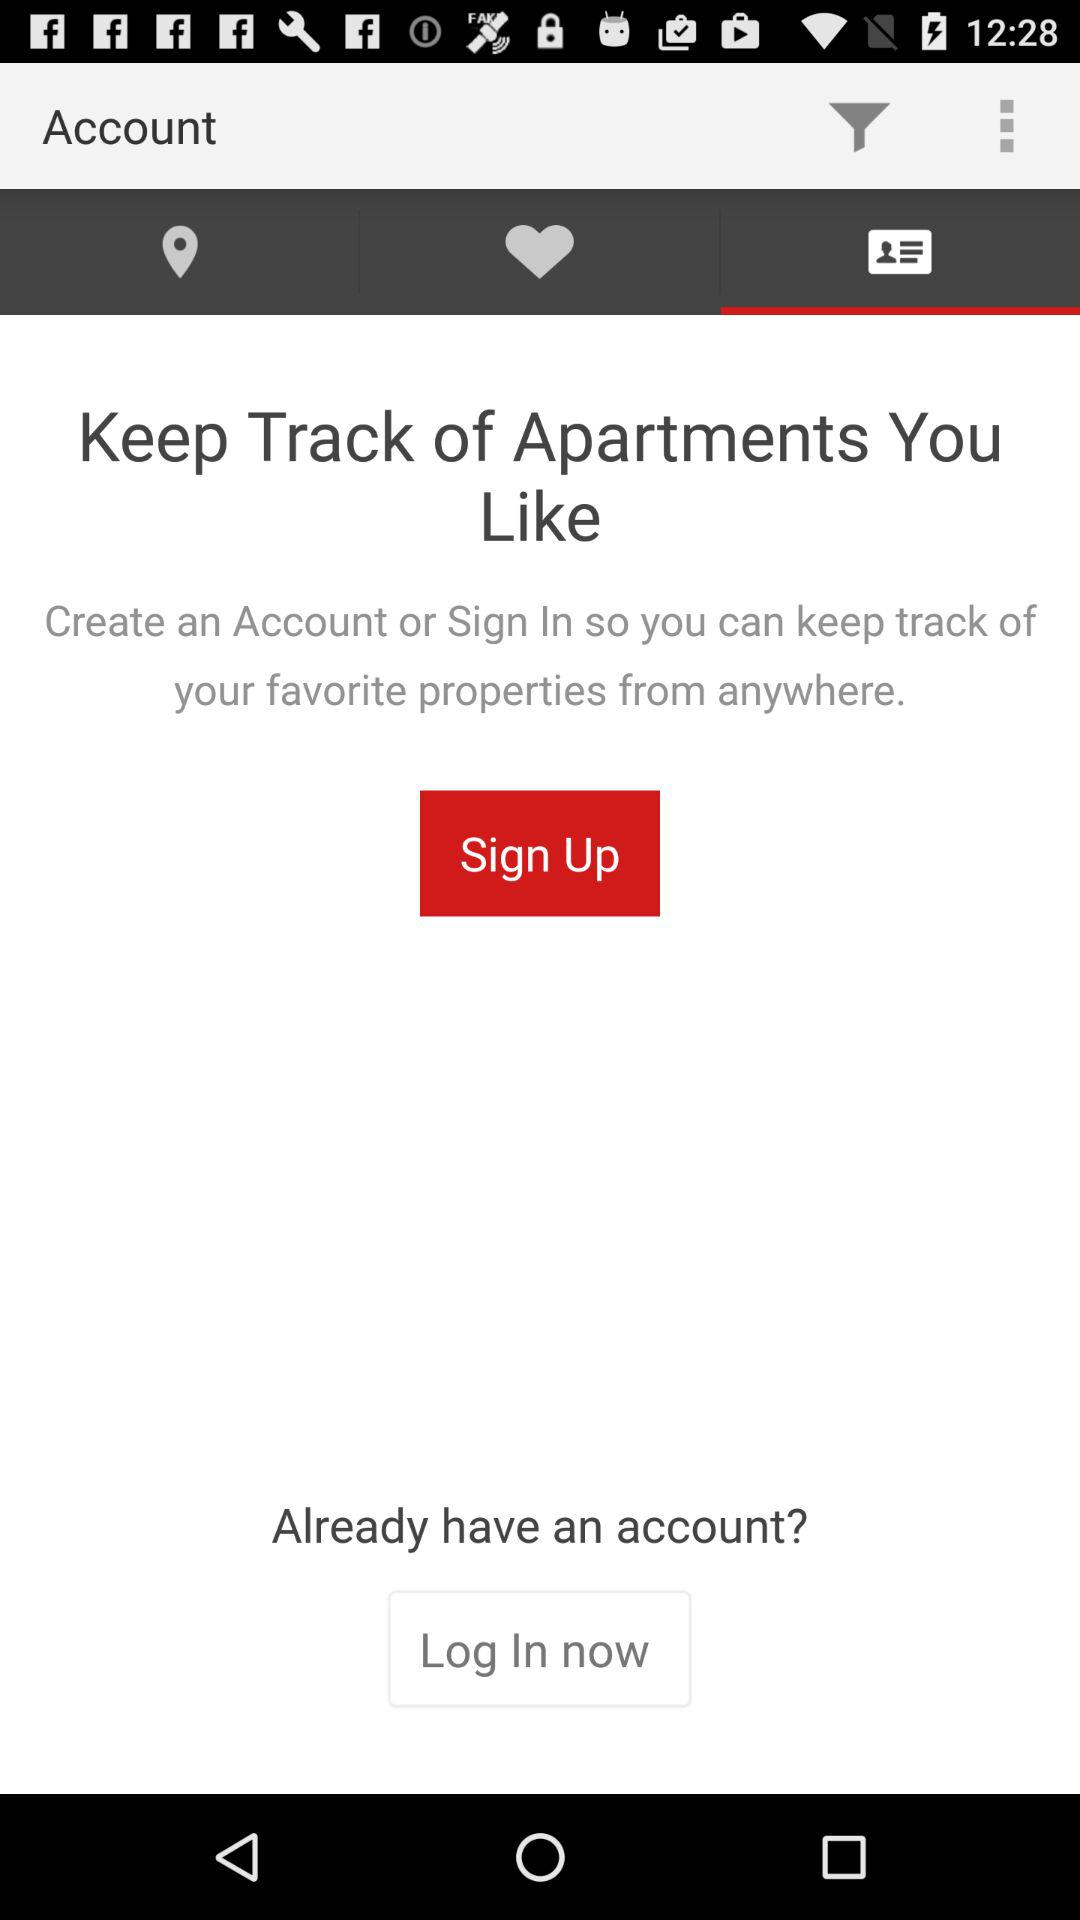Which is the selected tab? The selected tab is "Account". 